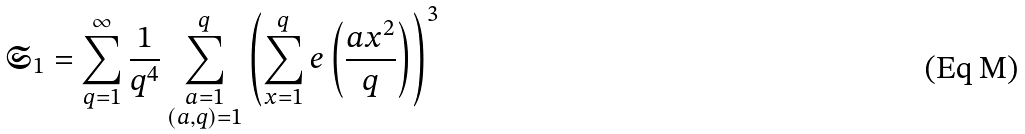Convert formula to latex. <formula><loc_0><loc_0><loc_500><loc_500>\mathfrak { S } _ { 1 } = \sum _ { q = 1 } ^ { \infty } \frac { 1 } { q ^ { 4 } } \sum _ { \substack { a = 1 \\ ( a , q ) = 1 } } ^ { q } \left ( \sum _ { x = 1 } ^ { q } e \left ( \frac { a x ^ { 2 } } { q } \right ) \right ) ^ { 3 }</formula> 